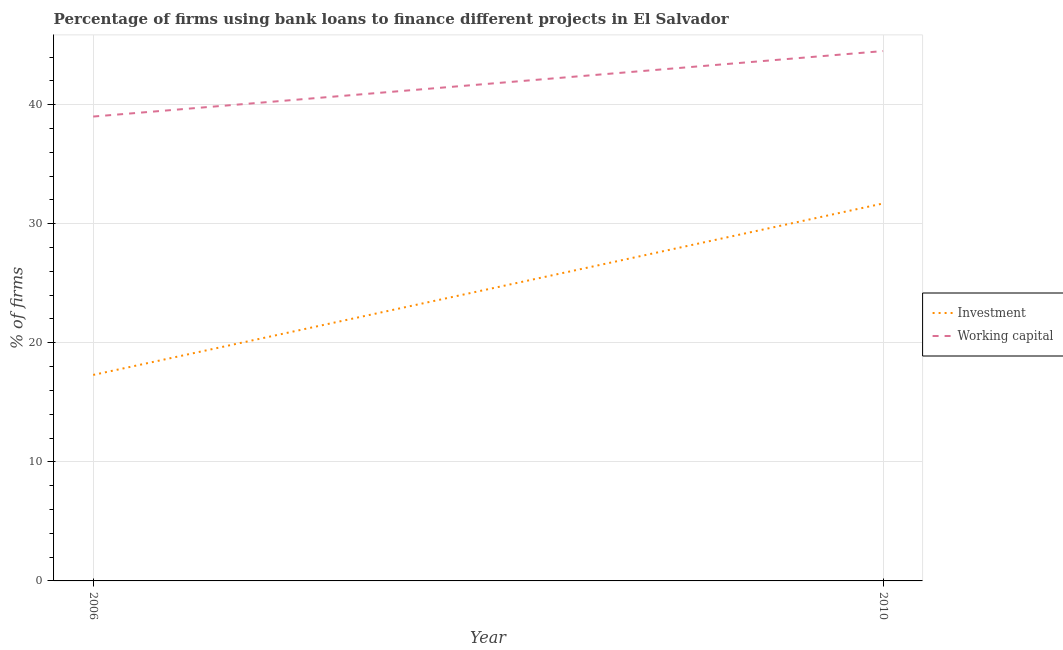How many different coloured lines are there?
Provide a short and direct response. 2. Across all years, what is the maximum percentage of firms using banks to finance investment?
Provide a short and direct response. 31.7. Across all years, what is the minimum percentage of firms using banks to finance working capital?
Offer a very short reply. 39. In which year was the percentage of firms using banks to finance investment maximum?
Offer a terse response. 2010. In which year was the percentage of firms using banks to finance working capital minimum?
Your answer should be compact. 2006. What is the total percentage of firms using banks to finance investment in the graph?
Ensure brevity in your answer.  49. What is the difference between the percentage of firms using banks to finance investment in 2006 and that in 2010?
Give a very brief answer. -14.4. What is the difference between the percentage of firms using banks to finance working capital in 2006 and the percentage of firms using banks to finance investment in 2010?
Provide a short and direct response. 7.3. In the year 2006, what is the difference between the percentage of firms using banks to finance investment and percentage of firms using banks to finance working capital?
Provide a short and direct response. -21.7. In how many years, is the percentage of firms using banks to finance investment greater than 26 %?
Make the answer very short. 1. What is the ratio of the percentage of firms using banks to finance working capital in 2006 to that in 2010?
Your answer should be very brief. 0.88. In how many years, is the percentage of firms using banks to finance working capital greater than the average percentage of firms using banks to finance working capital taken over all years?
Provide a short and direct response. 1. Does the percentage of firms using banks to finance working capital monotonically increase over the years?
Give a very brief answer. Yes. Is the percentage of firms using banks to finance working capital strictly less than the percentage of firms using banks to finance investment over the years?
Provide a succinct answer. No. How many years are there in the graph?
Make the answer very short. 2. Are the values on the major ticks of Y-axis written in scientific E-notation?
Provide a short and direct response. No. Does the graph contain any zero values?
Make the answer very short. No. Does the graph contain grids?
Your answer should be very brief. Yes. How are the legend labels stacked?
Offer a very short reply. Vertical. What is the title of the graph?
Offer a terse response. Percentage of firms using bank loans to finance different projects in El Salvador. What is the label or title of the X-axis?
Give a very brief answer. Year. What is the label or title of the Y-axis?
Offer a terse response. % of firms. What is the % of firms in Investment in 2010?
Offer a terse response. 31.7. What is the % of firms of Working capital in 2010?
Your answer should be very brief. 44.5. Across all years, what is the maximum % of firms in Investment?
Provide a succinct answer. 31.7. Across all years, what is the maximum % of firms of Working capital?
Your answer should be compact. 44.5. What is the total % of firms of Working capital in the graph?
Make the answer very short. 83.5. What is the difference between the % of firms in Investment in 2006 and that in 2010?
Your answer should be very brief. -14.4. What is the difference between the % of firms in Working capital in 2006 and that in 2010?
Provide a succinct answer. -5.5. What is the difference between the % of firms of Investment in 2006 and the % of firms of Working capital in 2010?
Ensure brevity in your answer.  -27.2. What is the average % of firms of Investment per year?
Make the answer very short. 24.5. What is the average % of firms in Working capital per year?
Offer a very short reply. 41.75. In the year 2006, what is the difference between the % of firms in Investment and % of firms in Working capital?
Your answer should be compact. -21.7. What is the ratio of the % of firms of Investment in 2006 to that in 2010?
Ensure brevity in your answer.  0.55. What is the ratio of the % of firms in Working capital in 2006 to that in 2010?
Your answer should be compact. 0.88. What is the difference between the highest and the second highest % of firms of Investment?
Your answer should be very brief. 14.4. What is the difference between the highest and the lowest % of firms of Investment?
Keep it short and to the point. 14.4. What is the difference between the highest and the lowest % of firms of Working capital?
Your response must be concise. 5.5. 